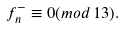<formula> <loc_0><loc_0><loc_500><loc_500>f _ { n } ^ { - } \equiv 0 ( m o d \, 1 3 ) .</formula> 